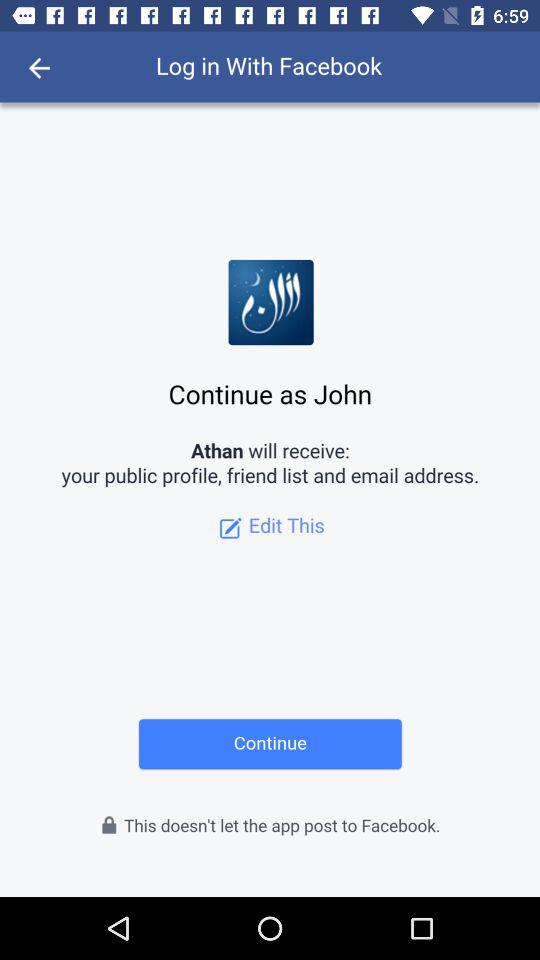What is the user's name? The user's name is John. 